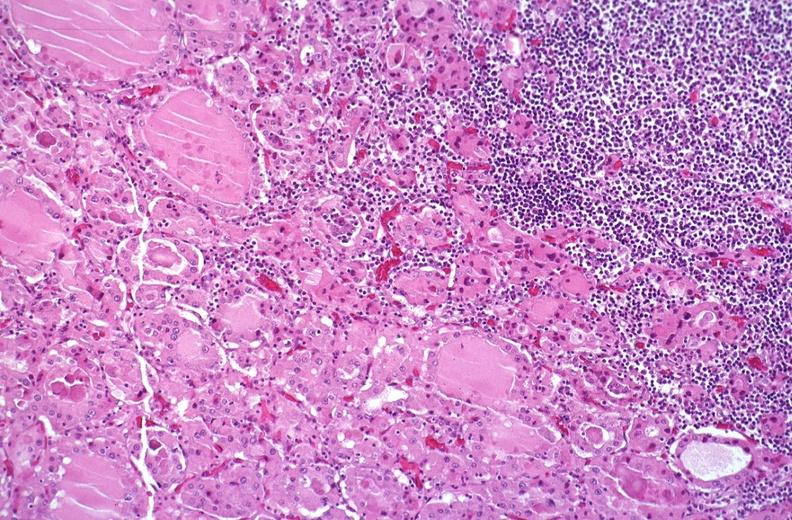what does this image show?
Answer the question using a single word or phrase. Hashimoto 's thyroiditis 